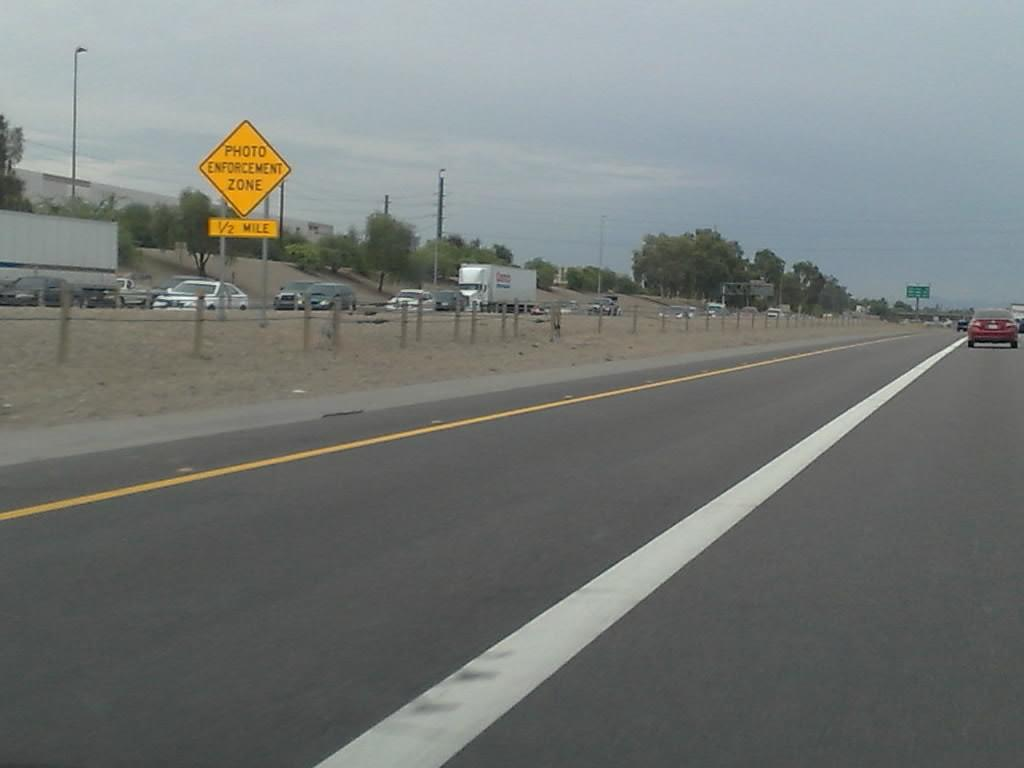<image>
Present a compact description of the photo's key features. A yellow, photo enforcement road sign is between the two lanes of traffic, on the highway. 